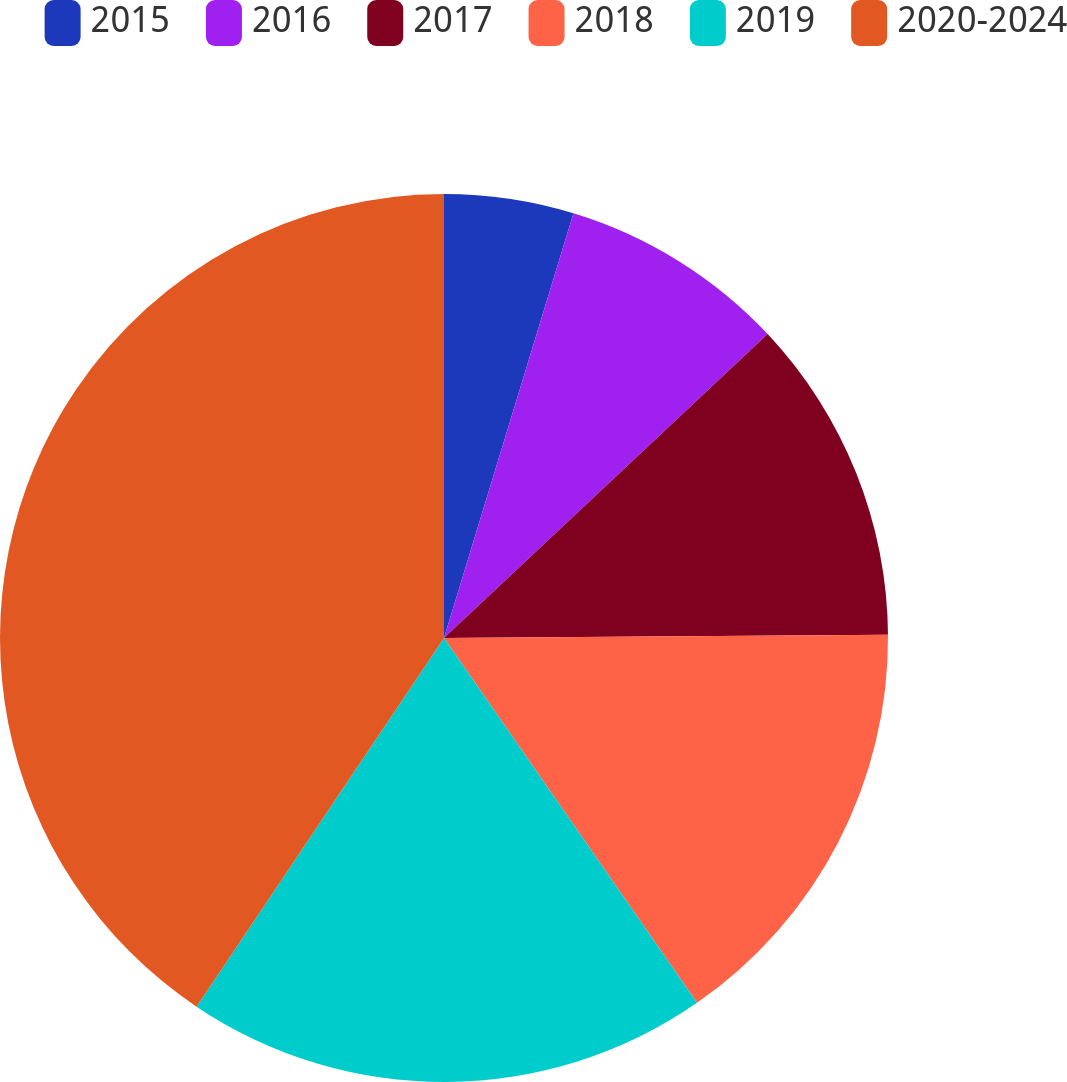Convert chart to OTSL. <chart><loc_0><loc_0><loc_500><loc_500><pie_chart><fcel>2015<fcel>2016<fcel>2017<fcel>2018<fcel>2019<fcel>2020-2024<nl><fcel>4.71%<fcel>8.29%<fcel>11.88%<fcel>15.47%<fcel>19.06%<fcel>40.59%<nl></chart> 